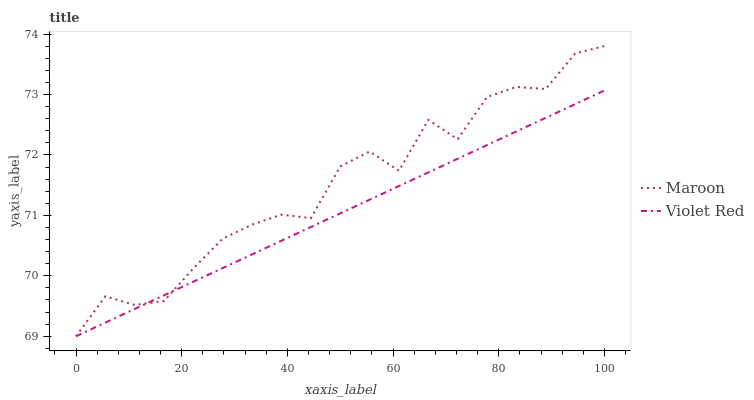Does Violet Red have the minimum area under the curve?
Answer yes or no. Yes. Does Maroon have the maximum area under the curve?
Answer yes or no. Yes. Does Maroon have the minimum area under the curve?
Answer yes or no. No. Is Violet Red the smoothest?
Answer yes or no. Yes. Is Maroon the roughest?
Answer yes or no. Yes. Is Maroon the smoothest?
Answer yes or no. No. Does Violet Red have the lowest value?
Answer yes or no. Yes. Does Maroon have the highest value?
Answer yes or no. Yes. Does Maroon intersect Violet Red?
Answer yes or no. Yes. Is Maroon less than Violet Red?
Answer yes or no. No. Is Maroon greater than Violet Red?
Answer yes or no. No. 